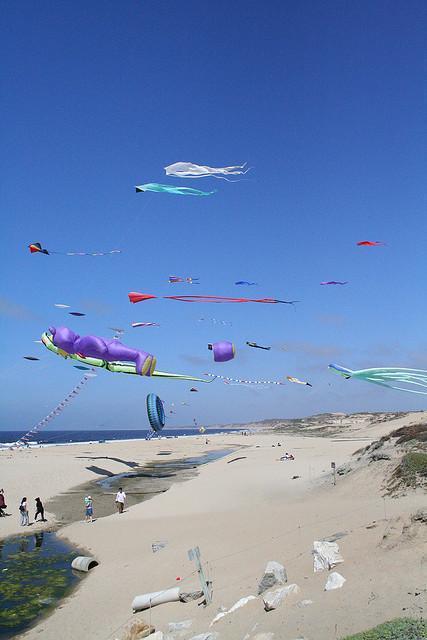How many clouds are above the kites?
Give a very brief answer. 0. How many kites are there?
Give a very brief answer. 2. 